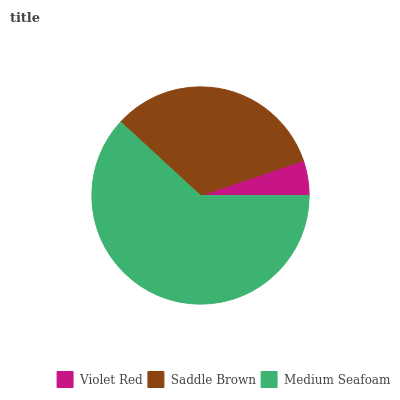Is Violet Red the minimum?
Answer yes or no. Yes. Is Medium Seafoam the maximum?
Answer yes or no. Yes. Is Saddle Brown the minimum?
Answer yes or no. No. Is Saddle Brown the maximum?
Answer yes or no. No. Is Saddle Brown greater than Violet Red?
Answer yes or no. Yes. Is Violet Red less than Saddle Brown?
Answer yes or no. Yes. Is Violet Red greater than Saddle Brown?
Answer yes or no. No. Is Saddle Brown less than Violet Red?
Answer yes or no. No. Is Saddle Brown the high median?
Answer yes or no. Yes. Is Saddle Brown the low median?
Answer yes or no. Yes. Is Medium Seafoam the high median?
Answer yes or no. No. Is Medium Seafoam the low median?
Answer yes or no. No. 